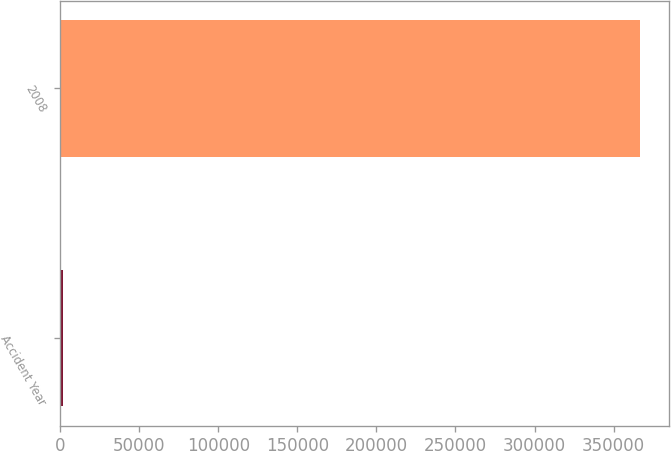<chart> <loc_0><loc_0><loc_500><loc_500><bar_chart><fcel>Accident Year<fcel>2008<nl><fcel>2017<fcel>366991<nl></chart> 